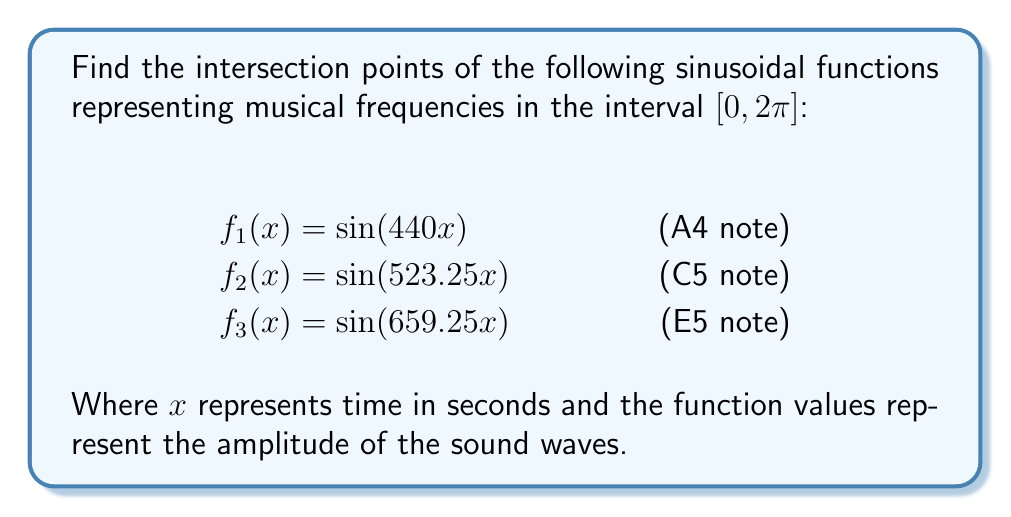Show me your answer to this math problem. To find the intersection points, we need to solve the system of equations:

$$
\begin{cases}
\sin(440x) = \sin(523.25x) \\
\sin(523.25x) = \sin(659.25x) \\
\sin(440x) = \sin(659.25x)
\end{cases}
$$

Step 1: Simplify using the trigonometric identity $\sin A = \sin B$ if and only if $A = B + 2\pi n$ or $A = \pi - B + 2\pi n$, where $n$ is an integer.

For $f_1$ and $f_2$:
$$440x = 523.25x + 2\pi n \text{ or } 440x = \pi - 523.25x + 2\pi n$$

For $f_2$ and $f_3$:
$$523.25x = 659.25x + 2\pi m \text{ or } 523.25x = \pi - 659.25x + 2\pi m$$

For $f_1$ and $f_3$:
$$440x = 659.25x + 2\pi k \text{ or } 440x = \pi - 659.25x + 2\pi k$$

Step 2: Solve these equations for $x$ in the interval $[0, 2\pi]$.

From $f_1$ and $f_2$:
$$x = \frac{2\pi n}{83.25} \text{ or } x = \frac{\pi}{963.25} + \frac{2\pi n}{963.25}$$

From $f_2$ and $f_3$:
$$x = \frac{2\pi m}{136} \text{ or } x = \frac{\pi}{1182.5} + \frac{2\pi m}{1182.5}$$

From $f_1$ and $f_3$:
$$x = \frac{2\pi k}{219.25} \text{ or } x = \frac{\pi}{1099.25} + \frac{2\pi k}{1099.25}$$

Step 3: Find common solutions that satisfy all three equations in the interval $[0, 2\pi]$.

The smallest common solution is at $x = \frac{2\pi}{219.25} \approx 0.0287$ seconds.

Step 4: To find all solutions in $[0, 2\pi]$, we multiply this value by integers until we exceed $2\pi$:

$$\frac{2\pi}{219.25}, \frac{4\pi}{219.25}, \frac{6\pi}{219.25}, ..., \frac{218\pi}{219.25}$$

This gives us 109 intersection points in the interval $[0, 2\pi]$.
Answer: 109 intersection points at $x = \frac{2k\pi}{219.25}$, where $k = 1, 2, ..., 109$. 